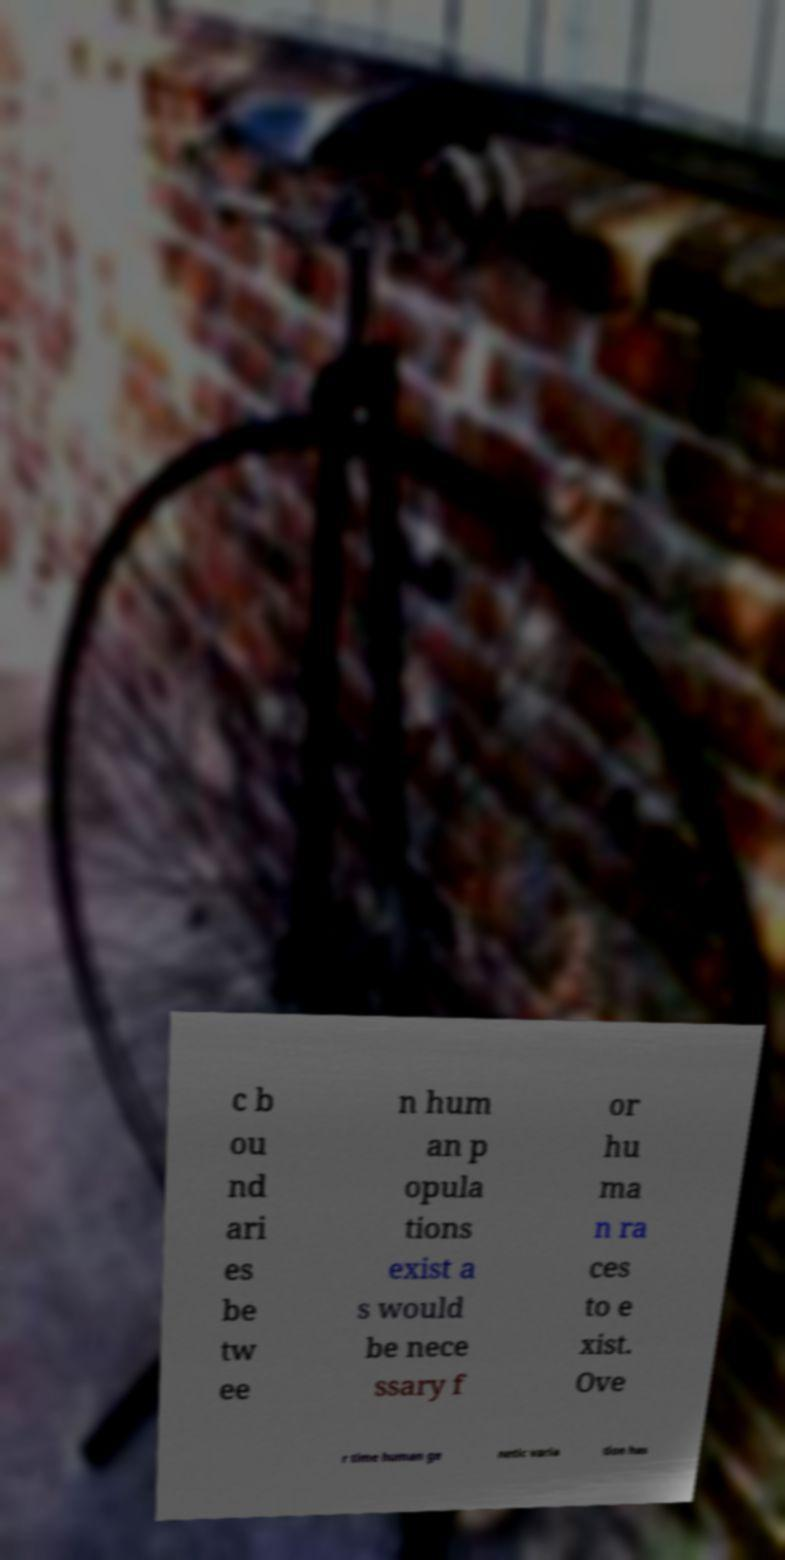Could you extract and type out the text from this image? c b ou nd ari es be tw ee n hum an p opula tions exist a s would be nece ssary f or hu ma n ra ces to e xist. Ove r time human ge netic varia tion has 